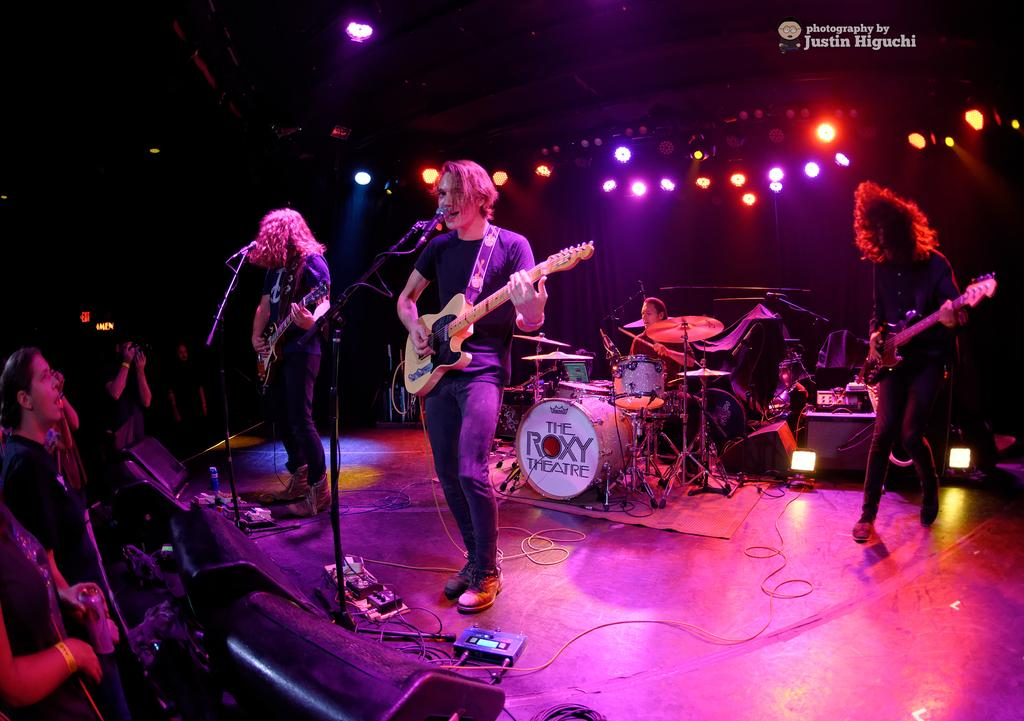What are the people in the image doing? The people in the image are playing musical instruments. What can be seen at the top of the image? There is a roof visible at the top of the image. What is providing illumination in the image? There are lights in the image. Where are the people standing in the image? There are people standing at the bottom left side of the image. What type of needle is being used by the manager in the image? There is no manager or needle present in the image. 